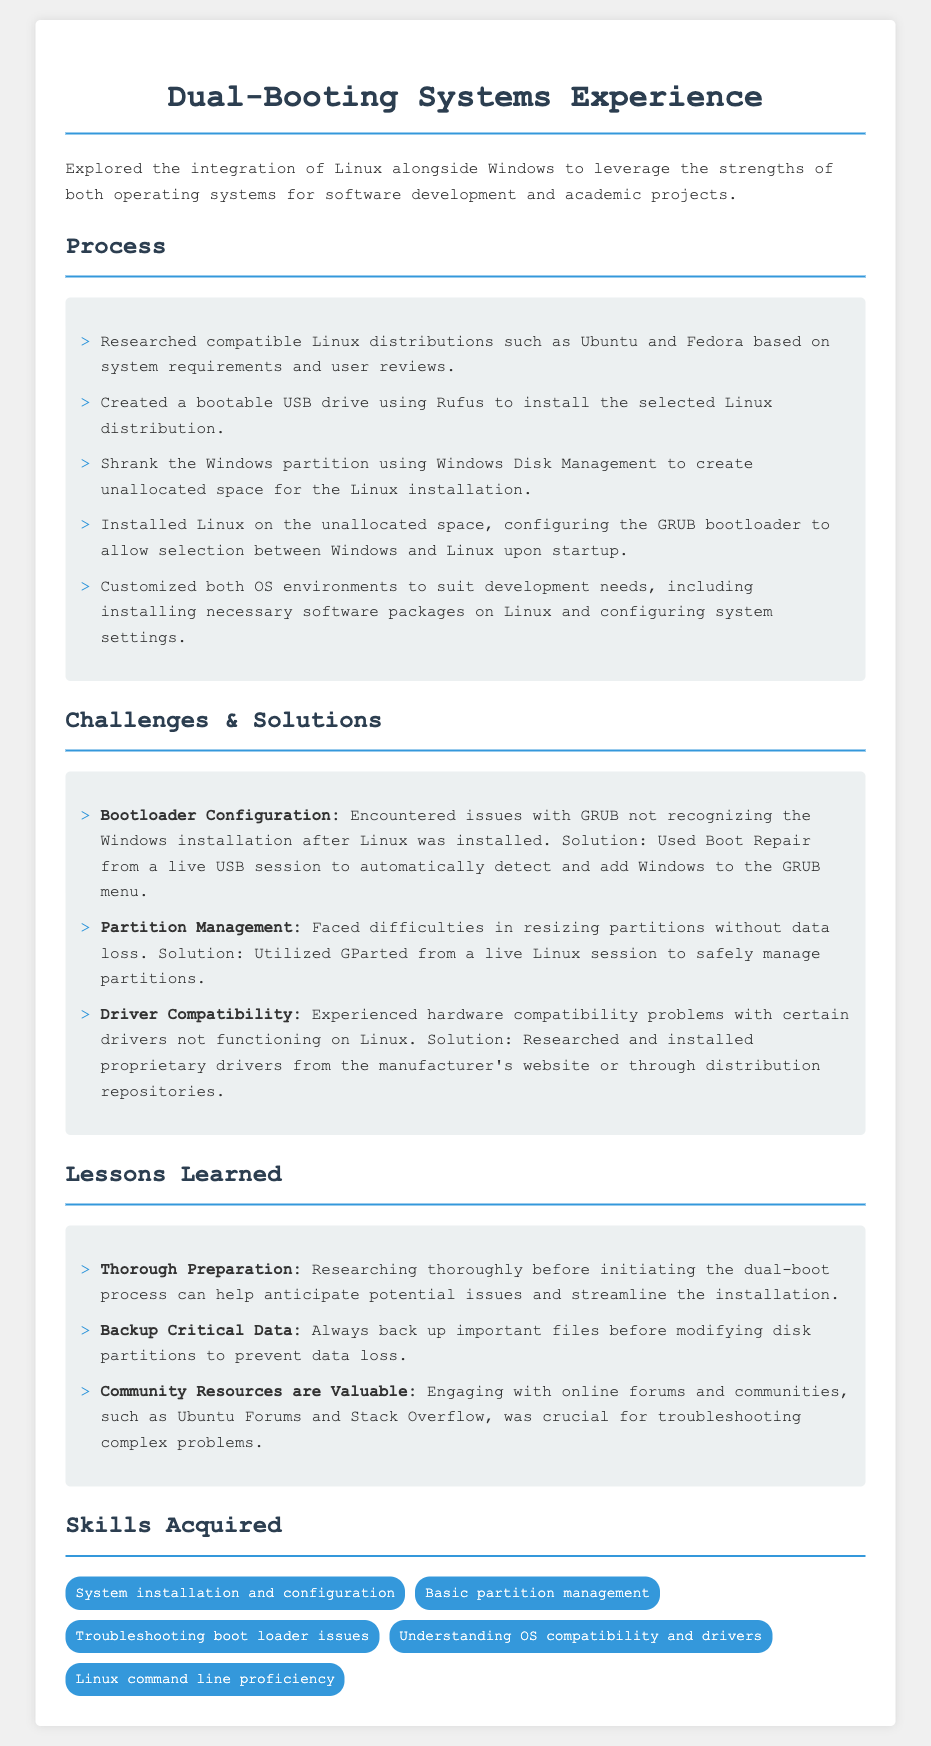What is the title of the document? The title of the document is explicitly stated at the top of the rendered output.
Answer: Dual-Booting Systems Experience Resume How many Linux distributions were researched? The document mentions that compatible Linux distributions were researched, specifically stating "such as Ubuntu and Fedora."
Answer: Two What was used to create a bootable USB drive? The document specifies the tool used for creating the bootable USB drive.
Answer: Rufus What software was utilized for partition management? The document names the software that was used to manage partitions during the Linux installation process.
Answer: GParted What type of data should be backed up before modifying disk partitions? The document advises on a critical action regarding data safety before partitioning.
Answer: Important files Which online resource is mentioned for troubleshooting? The document lists a type of community resource that proved valuable during troubleshooting.
Answer: Online forums What installation environment was customized after the installation? The document explains that both operating system environments were tailored to specific needs.
Answer: Both OS environments What issue was resolved using Boot Repair? The document clearly states the problem encountered with GRUB that was fixed using a specific tool.
Answer: GRUB not recognizing Windows 